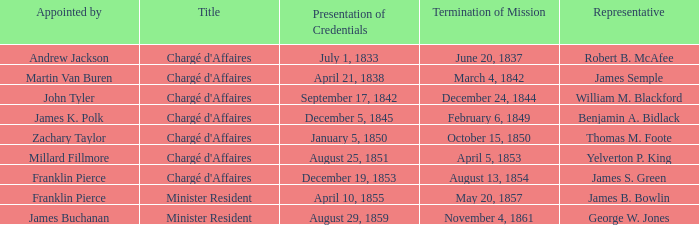What Title has a Termination of Mission for August 13, 1854? Chargé d'Affaires. 